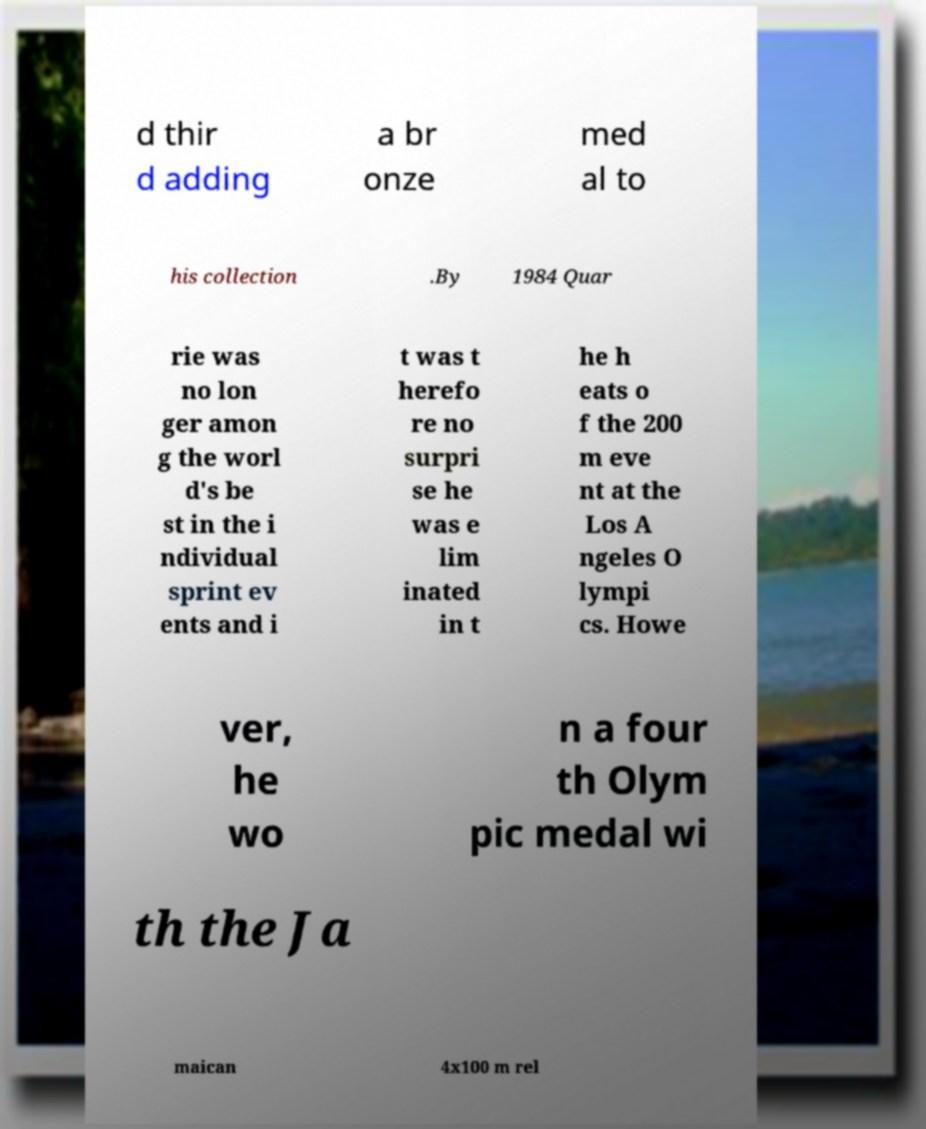Could you extract and type out the text from this image? d thir d adding a br onze med al to his collection .By 1984 Quar rie was no lon ger amon g the worl d's be st in the i ndividual sprint ev ents and i t was t herefo re no surpri se he was e lim inated in t he h eats o f the 200 m eve nt at the Los A ngeles O lympi cs. Howe ver, he wo n a four th Olym pic medal wi th the Ja maican 4x100 m rel 